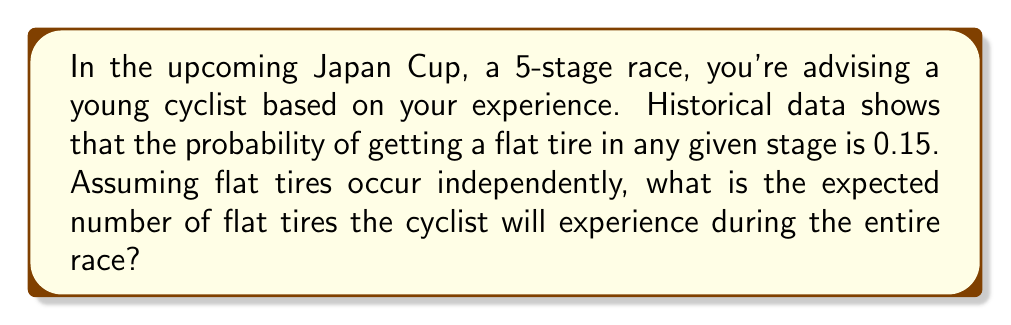What is the answer to this math problem? Let's approach this step-by-step:

1) First, we need to understand what "expected number" means. In probability theory, the expected value of a random variable is the sum of all possible values, each multiplied by its probability of occurrence.

2) In this case, we have a binomial probability distribution. The number of stages (n) is 5, and the probability (p) of a flat tire in each stage is 0.15.

3) For a binomial distribution, the expected value is given by the formula:

   $$ E(X) = np $$

   Where:
   $n$ = number of trials (stages in this case)
   $p$ = probability of success (getting a flat tire) in each trial

4) Substituting our values:

   $$ E(X) = 5 * 0.15 $$

5) Calculating:

   $$ E(X) = 0.75 $$

This means that, on average, we expect 0.75 flat tires over the course of the 5-stage race.
Answer: 0.75 flat tires 